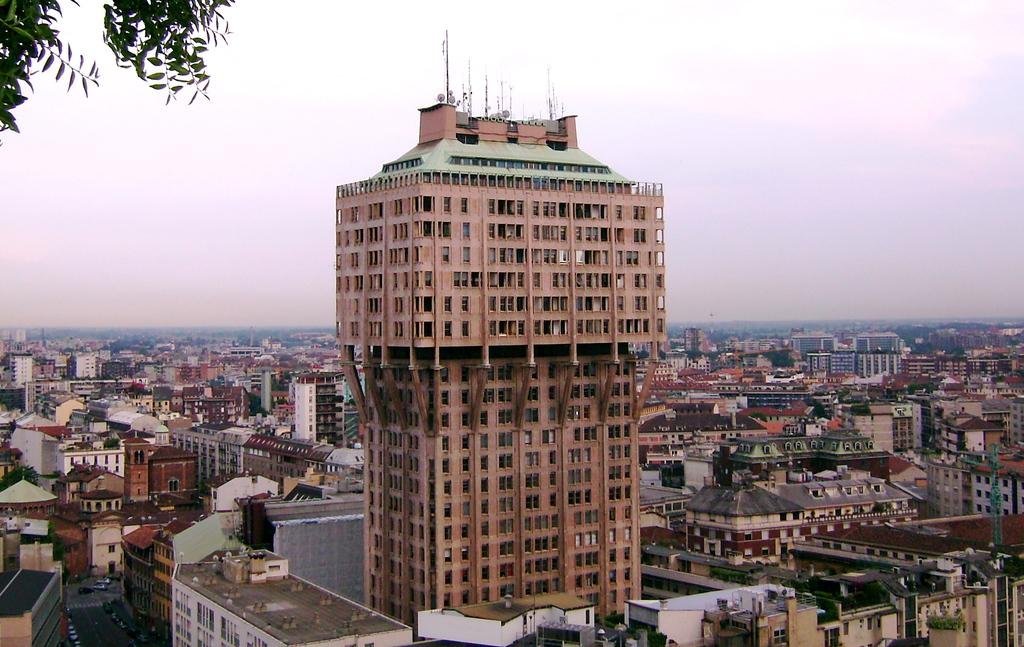What type of structures can be seen in the image? There are buildings in the image. What feature can be found on the buildings in the image? There are windows in the image. What type of vegetation is present in the image? There is a tree in the image. What is visible at the top of the image? The sky is visible at the top of the image. Is the beginner learning how to be a lawyer in the image? There is no indication of a beginner or a lawyer in the image; it features buildings, windows, a tree, and the sky. Where is the mailbox located in the image? There is no mailbox present in the image. 